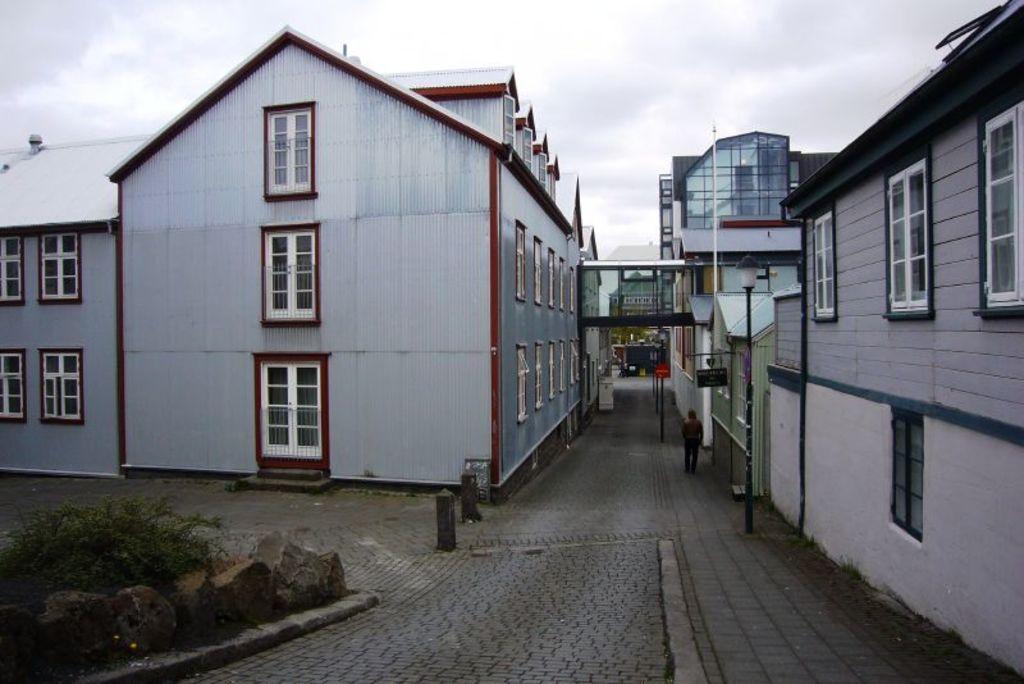Could you give a brief overview of what you see in this image? In this image we can see buildings, person, name boards, street lights and other objects. In the background of the image there is the sky. At the bottom of the image there is the road, rocks, plants and other objects. 